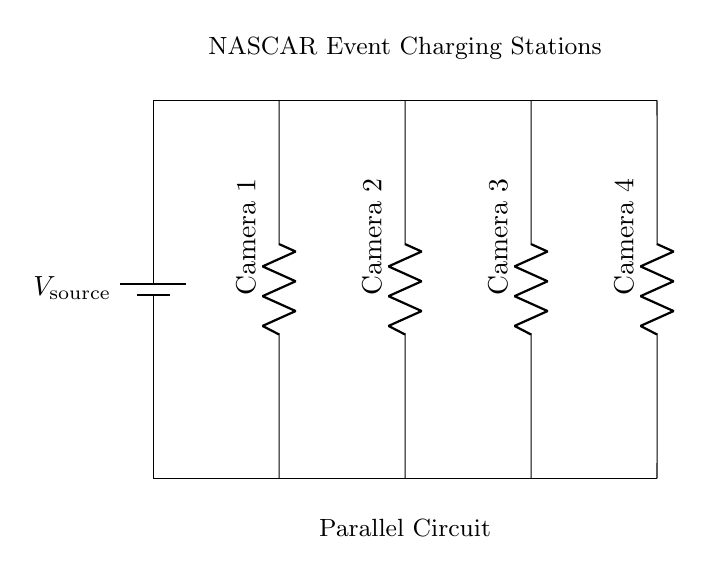What is the voltage source in the circuit? The circuit diagram indicates a single voltage source labeled V source connected across all components, providing the same voltage to each camera charger in the parallel configuration.
Answer: V source How many cameras are being charged in this circuit? The diagram clearly shows four resistors, each labeled as a camera (Camera 1, Camera 2, Camera 3, Camera 4), indicating that there are four cameras connected for charging.
Answer: Four What type of circuit is this? The circuit shows multiple branches with each camera connected directly to the voltage source, which allows the current to flow independently through each branch, characteristic of a parallel circuit.
Answer: Parallel Which camera has the least resistance? Since the diagram does not provide specific resistance values, in a typical scenario the camera with the least resistance would allow more current to flow. However, without the values, one can’t determine which specific camera has the least resistance just from the diagram.
Answer: Indeterminate What happens if one camera charger fails? In a parallel circuit, if one component (camera charger) fails, the remainder of the components continue to operate since each branch is independent of the others.
Answer: Other cameras continue charging What does the placement of the components tell us about the current flow? Each camera is connected directly to the voltage source; thus, the total current from the source splits into multiple paths, with each branch receiving the full source voltage and allowing independent operation.
Answer: Current splits across branches 